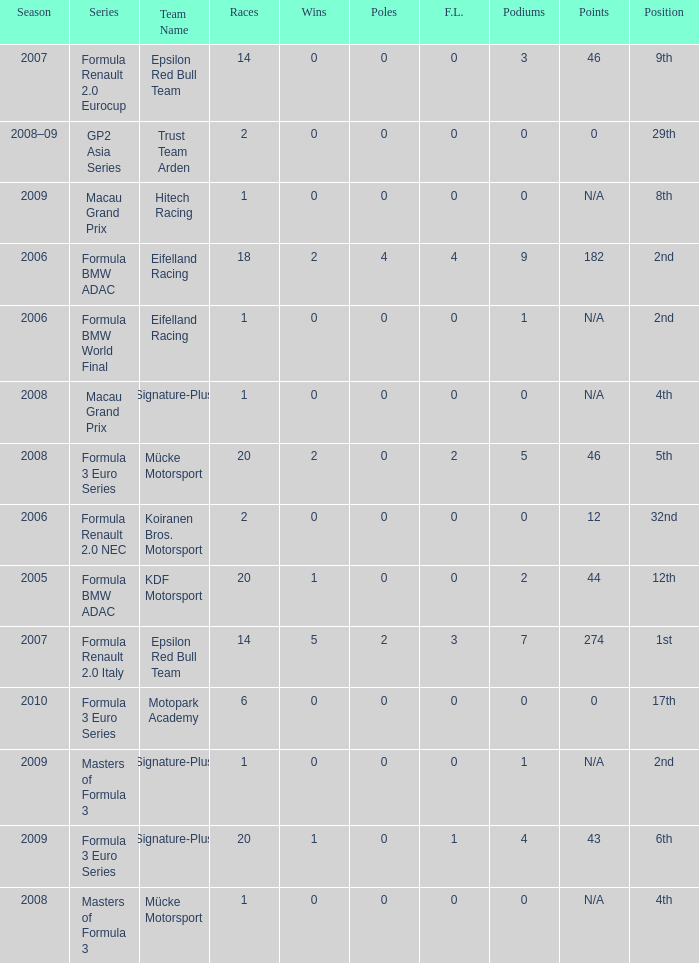What is the average number of podiums in the 32nd position with less than 0 wins? None. 